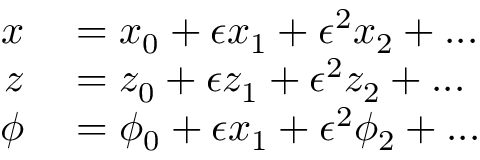Convert formula to latex. <formula><loc_0><loc_0><loc_500><loc_500>\begin{array} { r l } { x } & = x _ { 0 } + \epsilon x _ { 1 } + \epsilon ^ { 2 } x _ { 2 } + \dots } \\ { z } & = z _ { 0 } + \epsilon z _ { 1 } + \epsilon ^ { 2 } z _ { 2 } + \dots } \\ { \phi } & = \phi _ { 0 } + \epsilon x _ { 1 } + \epsilon ^ { 2 } \phi _ { 2 } + \dots } \end{array}</formula> 